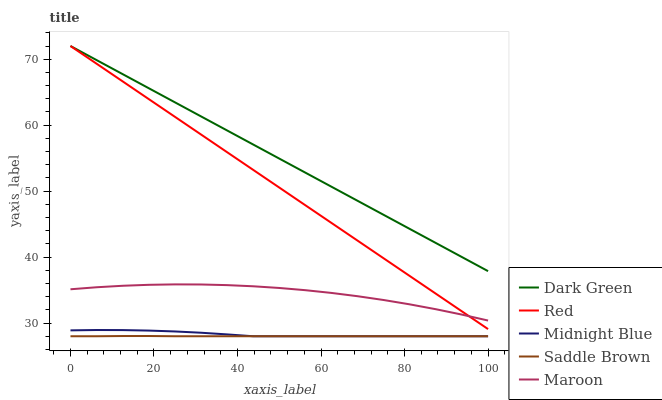Does Maroon have the minimum area under the curve?
Answer yes or no. No. Does Maroon have the maximum area under the curve?
Answer yes or no. No. Is Midnight Blue the smoothest?
Answer yes or no. No. Is Midnight Blue the roughest?
Answer yes or no. No. Does Maroon have the lowest value?
Answer yes or no. No. Does Maroon have the highest value?
Answer yes or no. No. Is Maroon less than Dark Green?
Answer yes or no. Yes. Is Dark Green greater than Maroon?
Answer yes or no. Yes. Does Maroon intersect Dark Green?
Answer yes or no. No. 